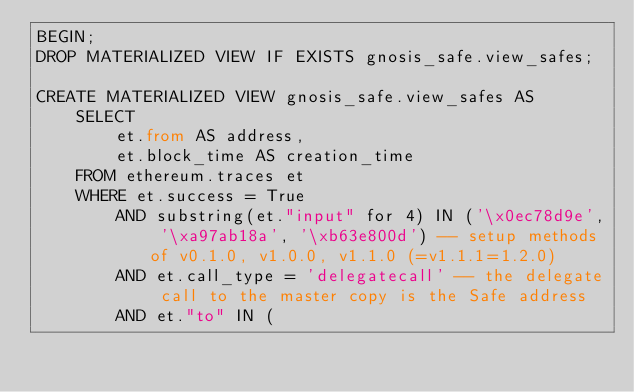Convert code to text. <code><loc_0><loc_0><loc_500><loc_500><_SQL_>BEGIN;
DROP MATERIALIZED VIEW IF EXISTS gnosis_safe.view_safes;

CREATE MATERIALIZED VIEW gnosis_safe.view_safes AS
    SELECT
    	et.from AS address,
    	et.block_time AS creation_time
    FROM ethereum.traces et 
    WHERE et.success = True
        AND substring(et."input" for 4) IN ('\x0ec78d9e', '\xa97ab18a', '\xb63e800d') -- setup methods of v0.1.0, v1.0.0, v1.1.0 (=v1.1.1=1.2.0)
        AND et.call_type = 'delegatecall' -- the delegate call to the master copy is the Safe address
        AND et."to" IN (</code> 